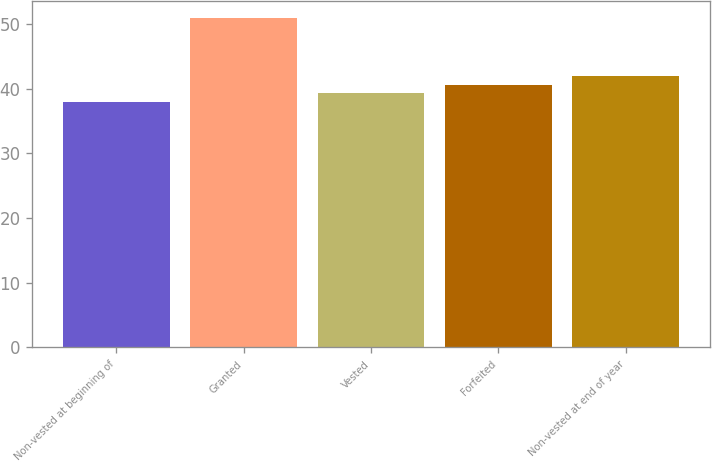<chart> <loc_0><loc_0><loc_500><loc_500><bar_chart><fcel>Non-vested at beginning of<fcel>Granted<fcel>Vested<fcel>Forfeited<fcel>Non-vested at end of year<nl><fcel>38<fcel>51<fcel>39.3<fcel>40.6<fcel>42<nl></chart> 